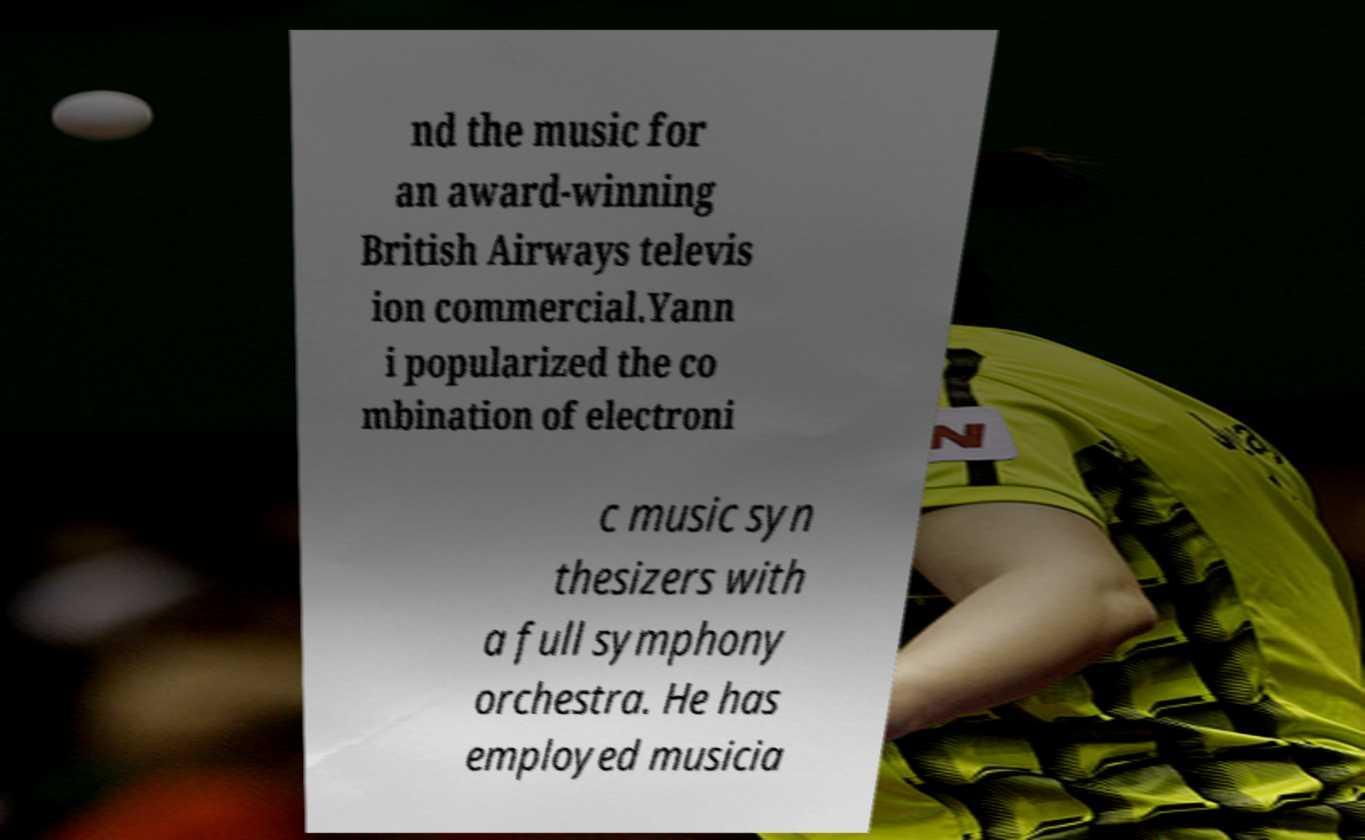I need the written content from this picture converted into text. Can you do that? nd the music for an award-winning British Airways televis ion commercial.Yann i popularized the co mbination of electroni c music syn thesizers with a full symphony orchestra. He has employed musicia 